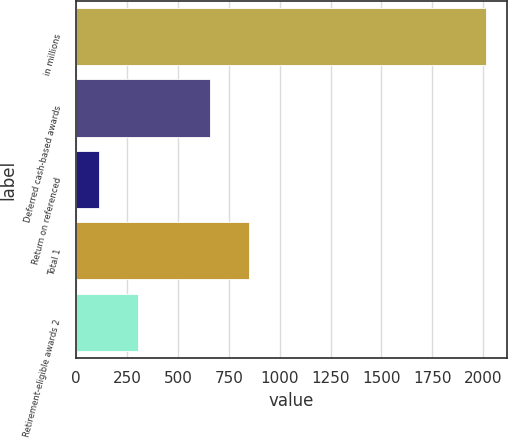Convert chart to OTSL. <chart><loc_0><loc_0><loc_500><loc_500><bar_chart><fcel>in millions<fcel>Deferred cash-based awards<fcel>Return on referenced<fcel>Total 1<fcel>Retirement-eligible awards 2<nl><fcel>2015<fcel>660<fcel>112<fcel>850.3<fcel>302.3<nl></chart> 